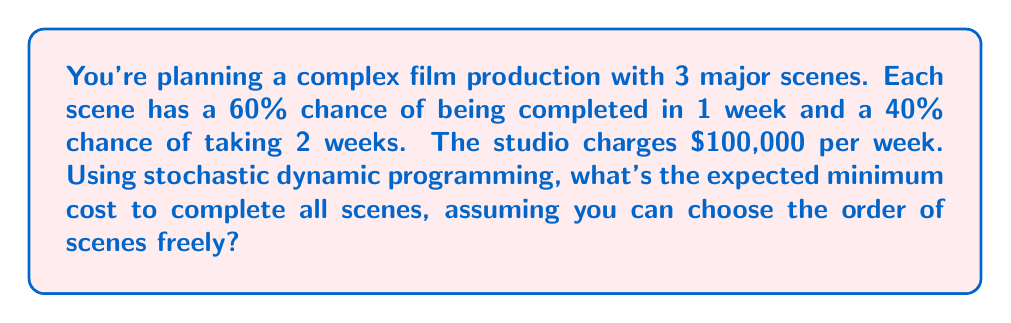Show me your answer to this math problem. Let's approach this using stochastic dynamic programming:

1) Define the state: Let $s_i$ be the state with $i$ scenes left to shoot.

2) Define the value function: Let $V(s_i)$ be the expected minimum cost to complete the remaining $i$ scenes.

3) Bellman equation:
   $$V(s_i) = 100000 + 0.6V(s_{i-1}) + 0.4V(s_{i-1})$$
   $$V(s_i) = 100000 + V(s_{i-1})$$

4) Boundary condition:
   $$V(s_0) = 0$$ (no scenes left means no cost)

5) Solve backwards:
   $$V(s_1) = 100000 + V(s_0) = 100000$$
   $$V(s_2) = 100000 + V(s_1) = 200000$$
   $$V(s_3) = 100000 + V(s_2) = 300000$$

The expected minimum cost to complete all 3 scenes is $V(s_3) = 300000$.

Note: The order of scenes doesn't matter in this case because each scene has the same probability distribution and the cost is linear with time.
Answer: $300,000 